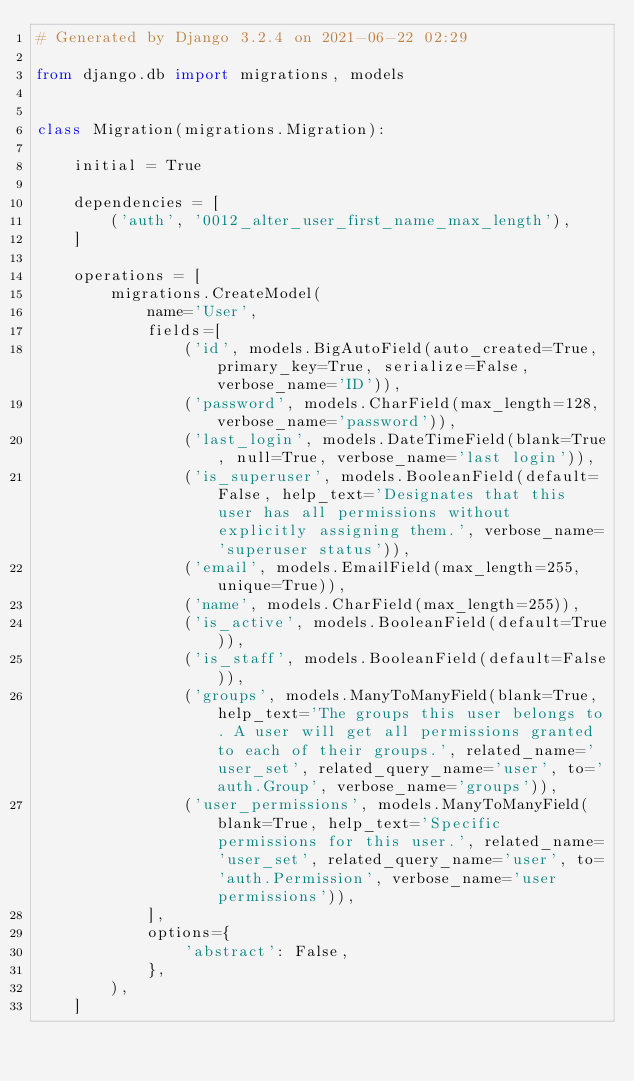Convert code to text. <code><loc_0><loc_0><loc_500><loc_500><_Python_># Generated by Django 3.2.4 on 2021-06-22 02:29

from django.db import migrations, models


class Migration(migrations.Migration):

    initial = True

    dependencies = [
        ('auth', '0012_alter_user_first_name_max_length'),
    ]

    operations = [
        migrations.CreateModel(
            name='User',
            fields=[
                ('id', models.BigAutoField(auto_created=True, primary_key=True, serialize=False, verbose_name='ID')),
                ('password', models.CharField(max_length=128, verbose_name='password')),
                ('last_login', models.DateTimeField(blank=True, null=True, verbose_name='last login')),
                ('is_superuser', models.BooleanField(default=False, help_text='Designates that this user has all permissions without explicitly assigning them.', verbose_name='superuser status')),
                ('email', models.EmailField(max_length=255, unique=True)),
                ('name', models.CharField(max_length=255)),
                ('is_active', models.BooleanField(default=True)),
                ('is_staff', models.BooleanField(default=False)),
                ('groups', models.ManyToManyField(blank=True, help_text='The groups this user belongs to. A user will get all permissions granted to each of their groups.', related_name='user_set', related_query_name='user', to='auth.Group', verbose_name='groups')),
                ('user_permissions', models.ManyToManyField(blank=True, help_text='Specific permissions for this user.', related_name='user_set', related_query_name='user', to='auth.Permission', verbose_name='user permissions')),
            ],
            options={
                'abstract': False,
            },
        ),
    ]
</code> 